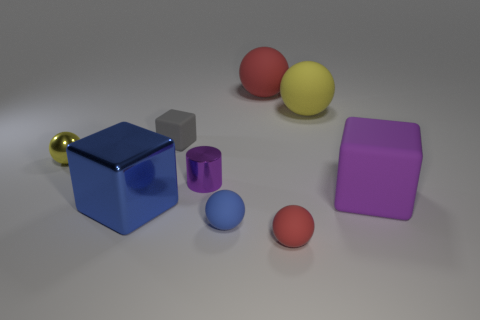There is a large matte sphere on the right side of the big red object; is there a tiny red sphere on the right side of it?
Provide a short and direct response. No. What is the material of the purple cylinder that is the same size as the gray object?
Your answer should be very brief. Metal. Are there any green cylinders of the same size as the gray matte thing?
Make the answer very short. No. There is a big cube that is right of the small blue matte object; what is its material?
Keep it short and to the point. Rubber. Does the ball on the left side of the cylinder have the same material as the small gray object?
Provide a short and direct response. No. The red object that is the same size as the metallic block is what shape?
Offer a terse response. Sphere. What number of big things have the same color as the tiny shiny cylinder?
Give a very brief answer. 1. Is the number of blue shiny cubes that are in front of the tiny blue rubber thing less than the number of small red rubber spheres on the left side of the large blue metallic object?
Provide a short and direct response. No. Are there any big purple blocks in front of the tiny red thing?
Offer a terse response. No. There is a purple object to the left of the yellow sphere that is right of the small red ball; are there any small blue rubber things that are to the left of it?
Provide a short and direct response. No. 